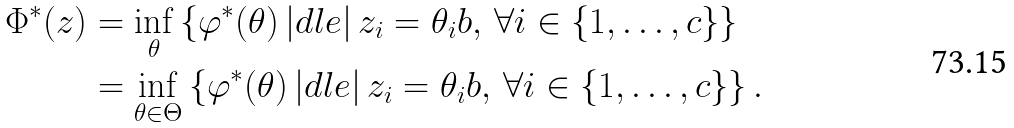Convert formula to latex. <formula><loc_0><loc_0><loc_500><loc_500>\Phi ^ { \ast } ( z ) & = \inf _ { \theta } \left \{ \varphi ^ { \ast } ( \theta ) \, | d l e | \, z _ { i } = \theta _ { i } b , \, \forall i \in \{ 1 , \dots , c \} \right \} \\ & = \inf _ { \theta \in \Theta } \left \{ \varphi ^ { \ast } ( \theta ) \, | d l e | \, z _ { i } = \theta _ { i } b , \, \forall i \in \{ 1 , \dots , c \} \right \} .</formula> 